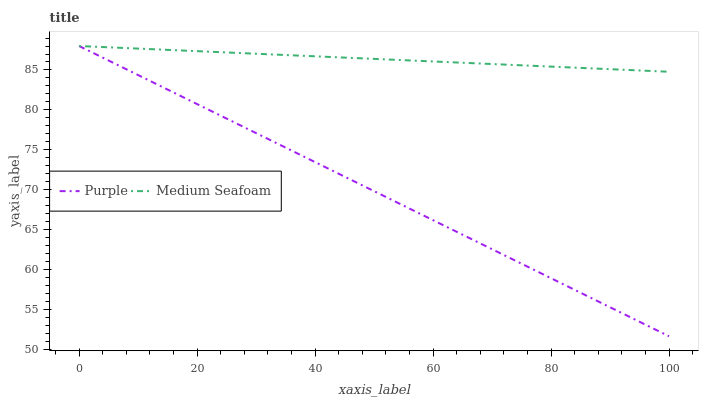Does Purple have the minimum area under the curve?
Answer yes or no. Yes. Does Medium Seafoam have the maximum area under the curve?
Answer yes or no. Yes. Does Medium Seafoam have the minimum area under the curve?
Answer yes or no. No. Is Medium Seafoam the smoothest?
Answer yes or no. Yes. Is Purple the roughest?
Answer yes or no. Yes. Is Medium Seafoam the roughest?
Answer yes or no. No. Does Purple have the lowest value?
Answer yes or no. Yes. Does Medium Seafoam have the lowest value?
Answer yes or no. No. Does Medium Seafoam have the highest value?
Answer yes or no. Yes. Does Medium Seafoam intersect Purple?
Answer yes or no. Yes. Is Medium Seafoam less than Purple?
Answer yes or no. No. Is Medium Seafoam greater than Purple?
Answer yes or no. No. 